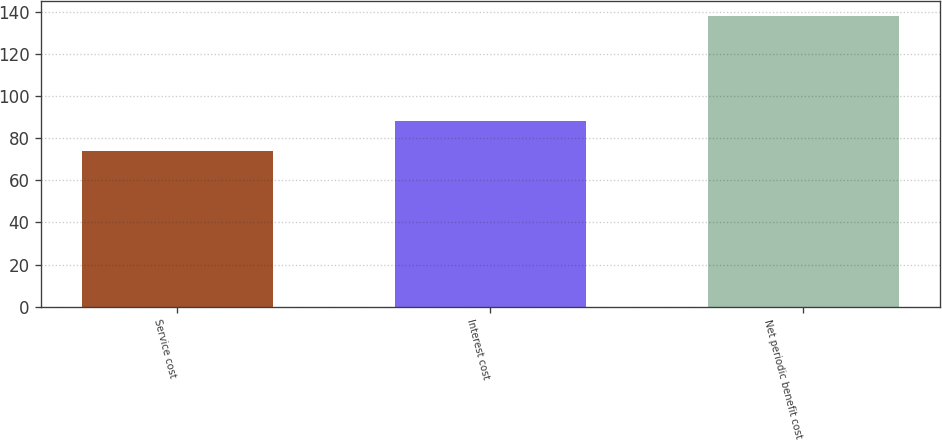Convert chart. <chart><loc_0><loc_0><loc_500><loc_500><bar_chart><fcel>Service cost<fcel>Interest cost<fcel>Net periodic benefit cost<nl><fcel>74<fcel>88<fcel>138<nl></chart> 